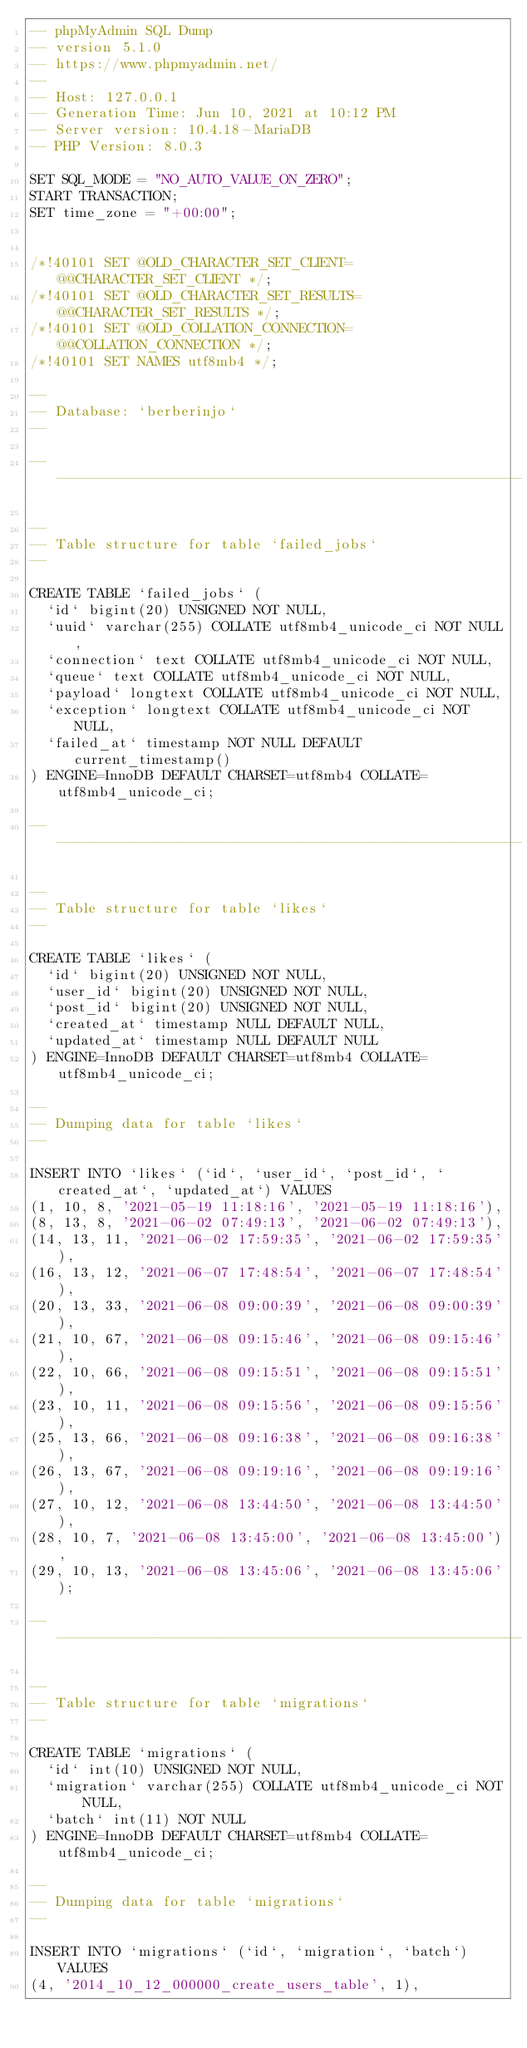<code> <loc_0><loc_0><loc_500><loc_500><_SQL_>-- phpMyAdmin SQL Dump
-- version 5.1.0
-- https://www.phpmyadmin.net/
--
-- Host: 127.0.0.1
-- Generation Time: Jun 10, 2021 at 10:12 PM
-- Server version: 10.4.18-MariaDB
-- PHP Version: 8.0.3

SET SQL_MODE = "NO_AUTO_VALUE_ON_ZERO";
START TRANSACTION;
SET time_zone = "+00:00";


/*!40101 SET @OLD_CHARACTER_SET_CLIENT=@@CHARACTER_SET_CLIENT */;
/*!40101 SET @OLD_CHARACTER_SET_RESULTS=@@CHARACTER_SET_RESULTS */;
/*!40101 SET @OLD_COLLATION_CONNECTION=@@COLLATION_CONNECTION */;
/*!40101 SET NAMES utf8mb4 */;

--
-- Database: `berberinjo`
--

-- --------------------------------------------------------

--
-- Table structure for table `failed_jobs`
--

CREATE TABLE `failed_jobs` (
  `id` bigint(20) UNSIGNED NOT NULL,
  `uuid` varchar(255) COLLATE utf8mb4_unicode_ci NOT NULL,
  `connection` text COLLATE utf8mb4_unicode_ci NOT NULL,
  `queue` text COLLATE utf8mb4_unicode_ci NOT NULL,
  `payload` longtext COLLATE utf8mb4_unicode_ci NOT NULL,
  `exception` longtext COLLATE utf8mb4_unicode_ci NOT NULL,
  `failed_at` timestamp NOT NULL DEFAULT current_timestamp()
) ENGINE=InnoDB DEFAULT CHARSET=utf8mb4 COLLATE=utf8mb4_unicode_ci;

-- --------------------------------------------------------

--
-- Table structure for table `likes`
--

CREATE TABLE `likes` (
  `id` bigint(20) UNSIGNED NOT NULL,
  `user_id` bigint(20) UNSIGNED NOT NULL,
  `post_id` bigint(20) UNSIGNED NOT NULL,
  `created_at` timestamp NULL DEFAULT NULL,
  `updated_at` timestamp NULL DEFAULT NULL
) ENGINE=InnoDB DEFAULT CHARSET=utf8mb4 COLLATE=utf8mb4_unicode_ci;

--
-- Dumping data for table `likes`
--

INSERT INTO `likes` (`id`, `user_id`, `post_id`, `created_at`, `updated_at`) VALUES
(1, 10, 8, '2021-05-19 11:18:16', '2021-05-19 11:18:16'),
(8, 13, 8, '2021-06-02 07:49:13', '2021-06-02 07:49:13'),
(14, 13, 11, '2021-06-02 17:59:35', '2021-06-02 17:59:35'),
(16, 13, 12, '2021-06-07 17:48:54', '2021-06-07 17:48:54'),
(20, 13, 33, '2021-06-08 09:00:39', '2021-06-08 09:00:39'),
(21, 10, 67, '2021-06-08 09:15:46', '2021-06-08 09:15:46'),
(22, 10, 66, '2021-06-08 09:15:51', '2021-06-08 09:15:51'),
(23, 10, 11, '2021-06-08 09:15:56', '2021-06-08 09:15:56'),
(25, 13, 66, '2021-06-08 09:16:38', '2021-06-08 09:16:38'),
(26, 13, 67, '2021-06-08 09:19:16', '2021-06-08 09:19:16'),
(27, 10, 12, '2021-06-08 13:44:50', '2021-06-08 13:44:50'),
(28, 10, 7, '2021-06-08 13:45:00', '2021-06-08 13:45:00'),
(29, 10, 13, '2021-06-08 13:45:06', '2021-06-08 13:45:06');

-- --------------------------------------------------------

--
-- Table structure for table `migrations`
--

CREATE TABLE `migrations` (
  `id` int(10) UNSIGNED NOT NULL,
  `migration` varchar(255) COLLATE utf8mb4_unicode_ci NOT NULL,
  `batch` int(11) NOT NULL
) ENGINE=InnoDB DEFAULT CHARSET=utf8mb4 COLLATE=utf8mb4_unicode_ci;

--
-- Dumping data for table `migrations`
--

INSERT INTO `migrations` (`id`, `migration`, `batch`) VALUES
(4, '2014_10_12_000000_create_users_table', 1),</code> 